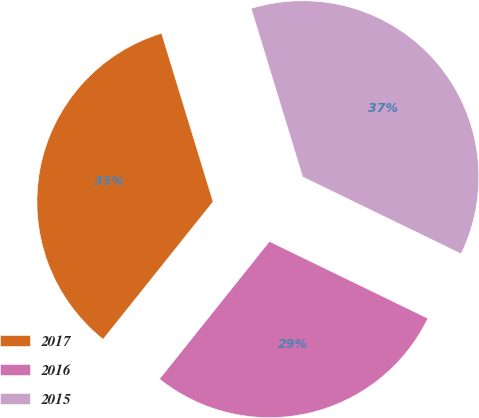Convert chart to OTSL. <chart><loc_0><loc_0><loc_500><loc_500><pie_chart><fcel>2017<fcel>2016<fcel>2015<nl><fcel>34.55%<fcel>28.54%<fcel>36.92%<nl></chart> 